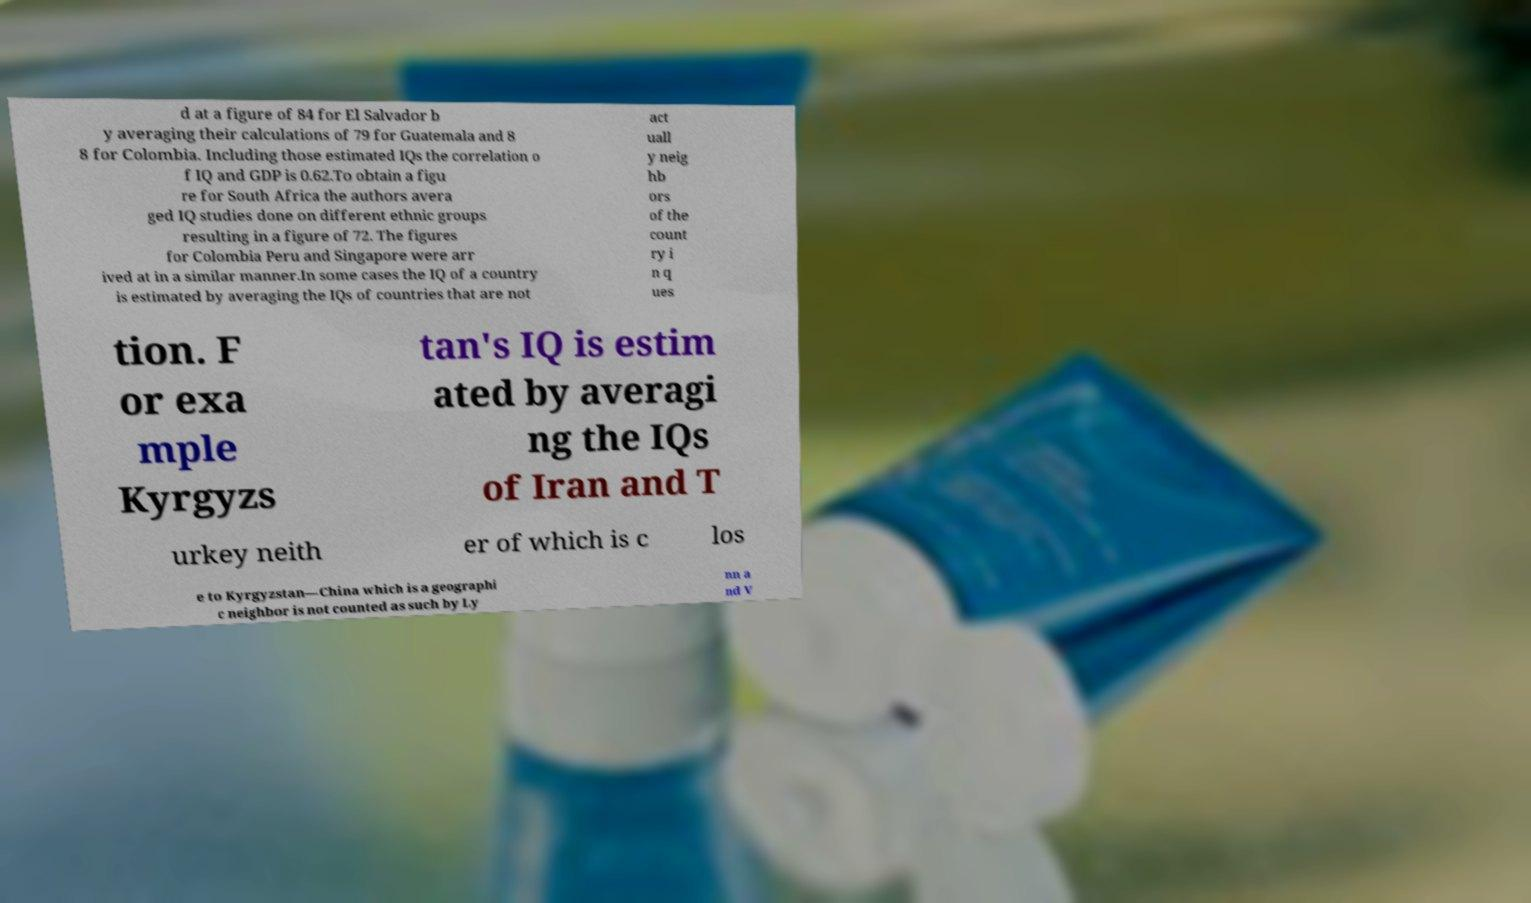Can you read and provide the text displayed in the image?This photo seems to have some interesting text. Can you extract and type it out for me? d at a figure of 84 for El Salvador b y averaging their calculations of 79 for Guatemala and 8 8 for Colombia. Including those estimated IQs the correlation o f IQ and GDP is 0.62.To obtain a figu re for South Africa the authors avera ged IQ studies done on different ethnic groups resulting in a figure of 72. The figures for Colombia Peru and Singapore were arr ived at in a similar manner.In some cases the IQ of a country is estimated by averaging the IQs of countries that are not act uall y neig hb ors of the count ry i n q ues tion. F or exa mple Kyrgyzs tan's IQ is estim ated by averagi ng the IQs of Iran and T urkey neith er of which is c los e to Kyrgyzstan—China which is a geographi c neighbor is not counted as such by Ly nn a nd V 